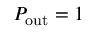Convert formula to latex. <formula><loc_0><loc_0><loc_500><loc_500>P _ { o u t } = 1</formula> 